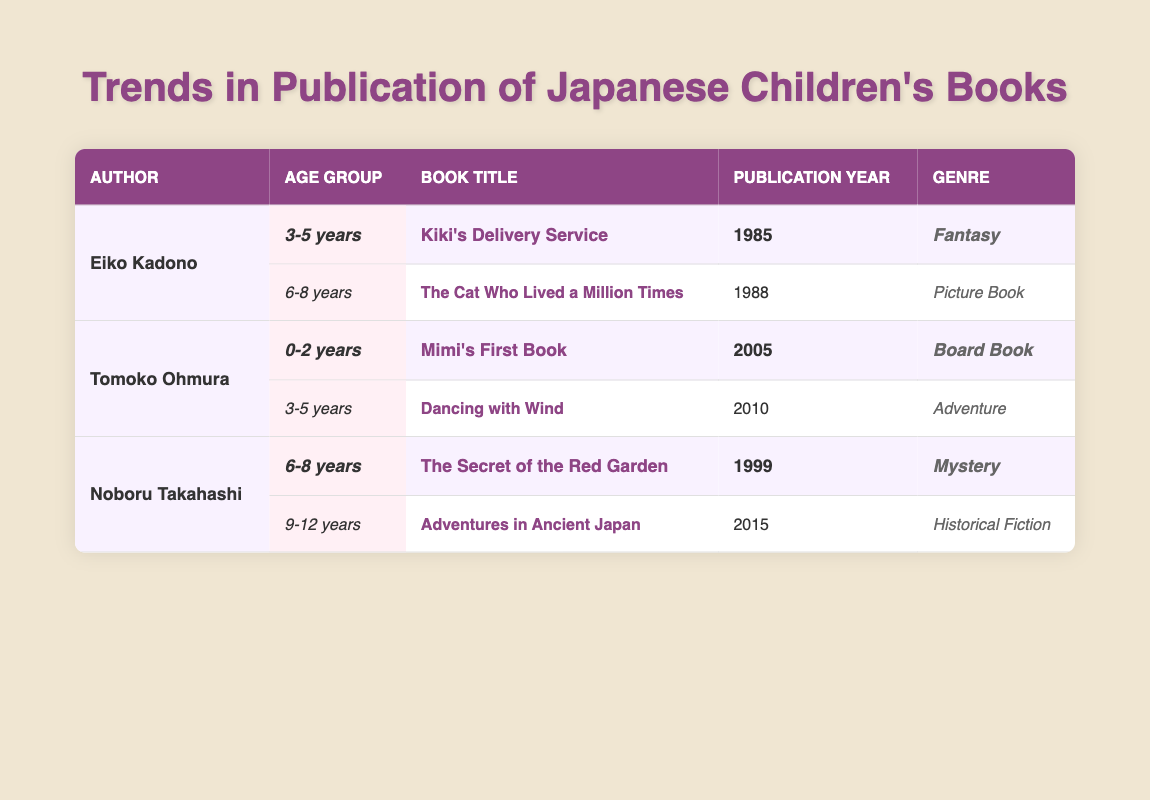What is the title of the book published by Eiko Kadono for the age group 3-5 years? The table indicates that Eiko Kadono wrote "Kiki's Delivery Service" for the age group 3-5 years.
Answer: Kiki's Delivery Service Which author wrote a book for the age group of 0-2 years? The table shows that Tomoko Ohmura has a book for the age group 0-2 years, titled "Mimi's First Book."
Answer: Tomoko Ohmura How many authors have published books for the age group 6-8 years? Eiko Kadono and Noboru Takahashi both have books listed for the age group 6-8 years, so there are 2 authors.
Answer: 2 authors Was "The Secret of the Red Garden" published before the year 2000? The table states that "The Secret of the Red Garden" by Noboru Takahashi was published in 1999, which is before the year 2000.
Answer: Yes Which genre does the book "Dancing with Wind" belong to? According to the table, "Dancing with Wind" is categorized under the Adventure genre.
Answer: Adventure Which author has the latest publication in the table? Comparing the publication years, Noboru Takahashi published "Adventures in Ancient Japan" in 2015, making it the latest.
Answer: Noboru Takahashi How many books does Tomoko Ohmura have published for the age group 3-5 years? The table indicates that Tomoko Ohmura has one book for the age group 3-5 years, titled "Dancing with Wind."
Answer: 1 book What is the average publication year for the books listed in the table? The publication years are 1985, 1988, 2005, 2010, 1999, and 2015. Summing these gives 1002, and there are 6 books. So, the average year is 1002/6 = 167.
Answer: 167 Which genre has the most books listed by the authors in the table? The table shows Fantasy, Picture Book, Board Book, Adventure, Mystery, and Historical Fiction. Each genre has one book, thus no genre has more.
Answer: None, all genres have one book each 